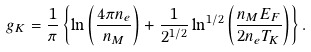<formula> <loc_0><loc_0><loc_500><loc_500>g _ { K } = \frac { 1 } { \pi } \left \{ \ln \left ( \frac { 4 \pi n _ { e } } { n _ { M } } \right ) + \frac { 1 } { 2 ^ { 1 / 2 } } \ln ^ { 1 / 2 } \left ( \frac { n _ { M } E _ { F } } { 2 n _ { e } T _ { K } } \right ) \right \} .</formula> 